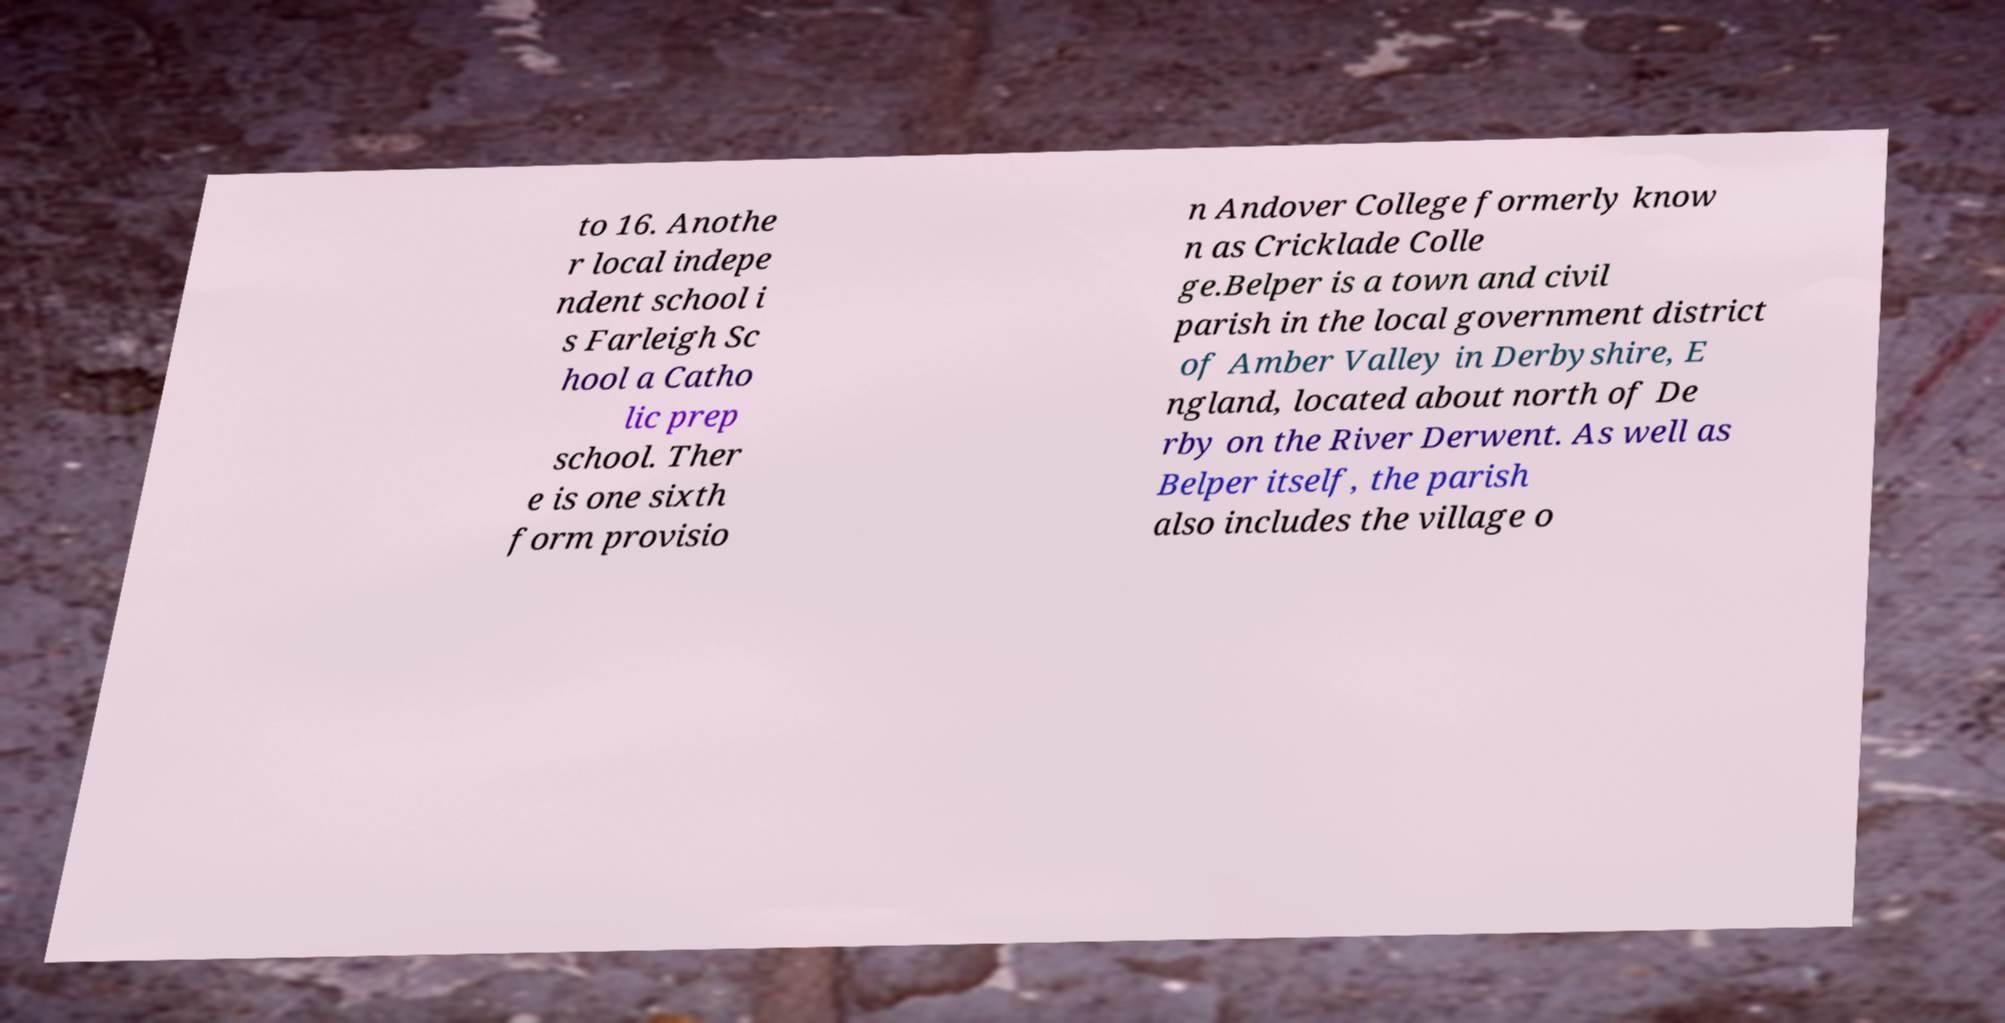Could you extract and type out the text from this image? to 16. Anothe r local indepe ndent school i s Farleigh Sc hool a Catho lic prep school. Ther e is one sixth form provisio n Andover College formerly know n as Cricklade Colle ge.Belper is a town and civil parish in the local government district of Amber Valley in Derbyshire, E ngland, located about north of De rby on the River Derwent. As well as Belper itself, the parish also includes the village o 